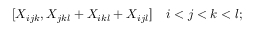Convert formula to latex. <formula><loc_0><loc_0><loc_500><loc_500>[ X _ { i j k } , X _ { j k l } + X _ { i k l } + X _ { i j l } ] \quad i < j < k < l ;</formula> 